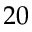Convert formula to latex. <formula><loc_0><loc_0><loc_500><loc_500>2 0</formula> 